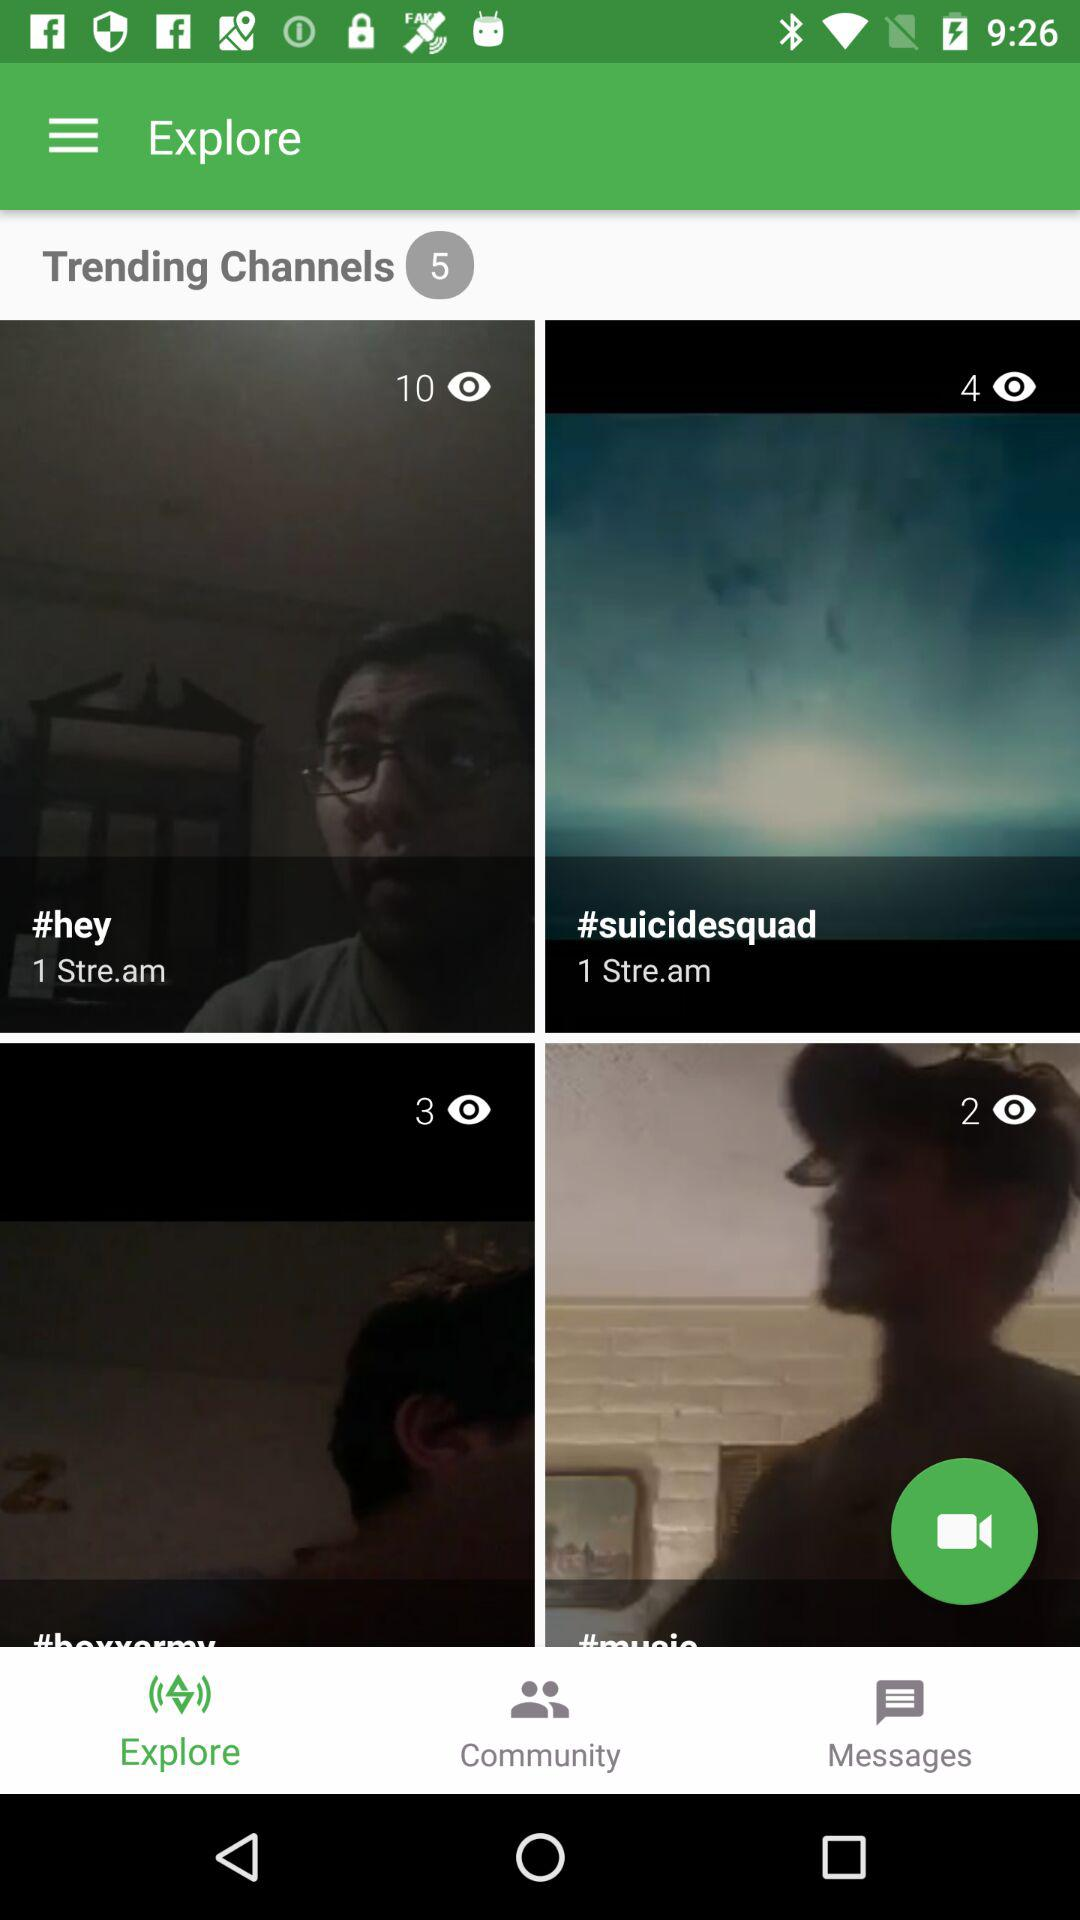How many views are there on "#suicidesquad"? There are 4 views on "#suicidesquad". 